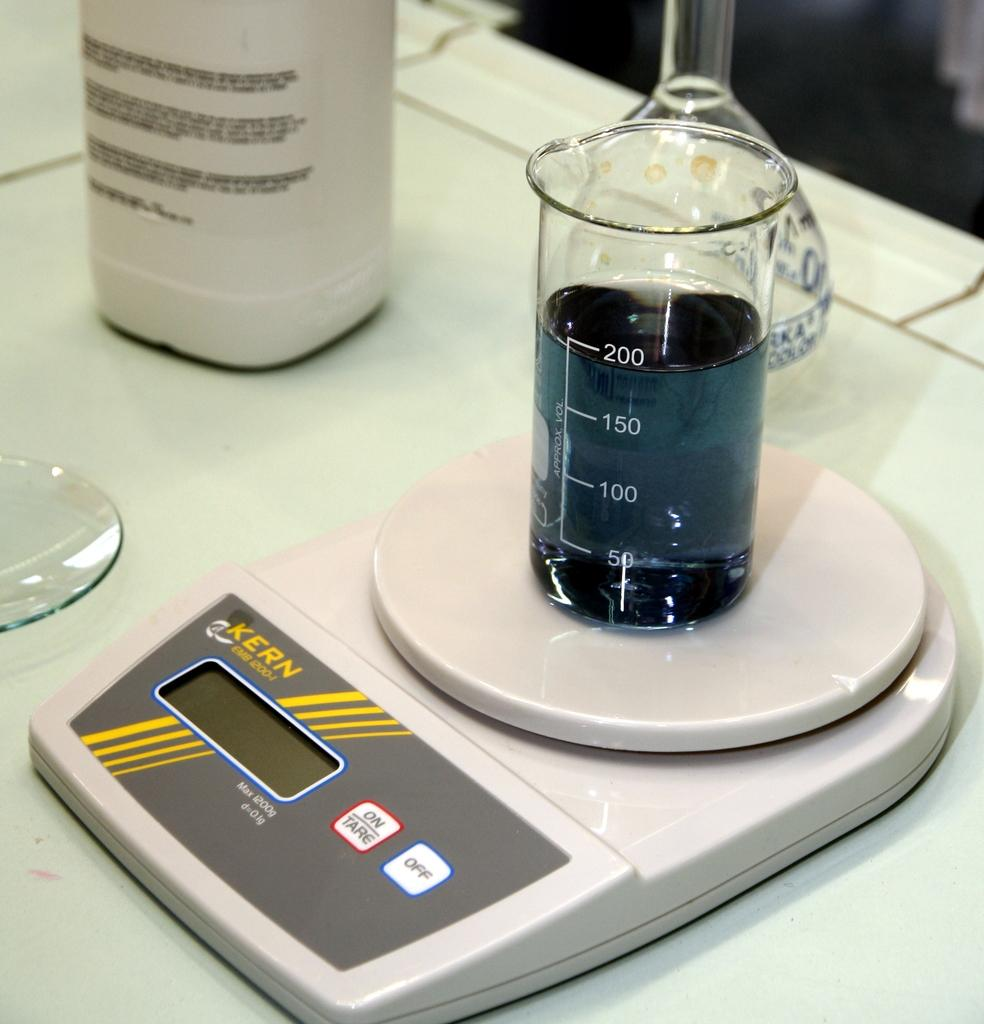<image>
Present a compact description of the photo's key features. A beaker with 200ml of black liquid sitting on an electronic balance. 